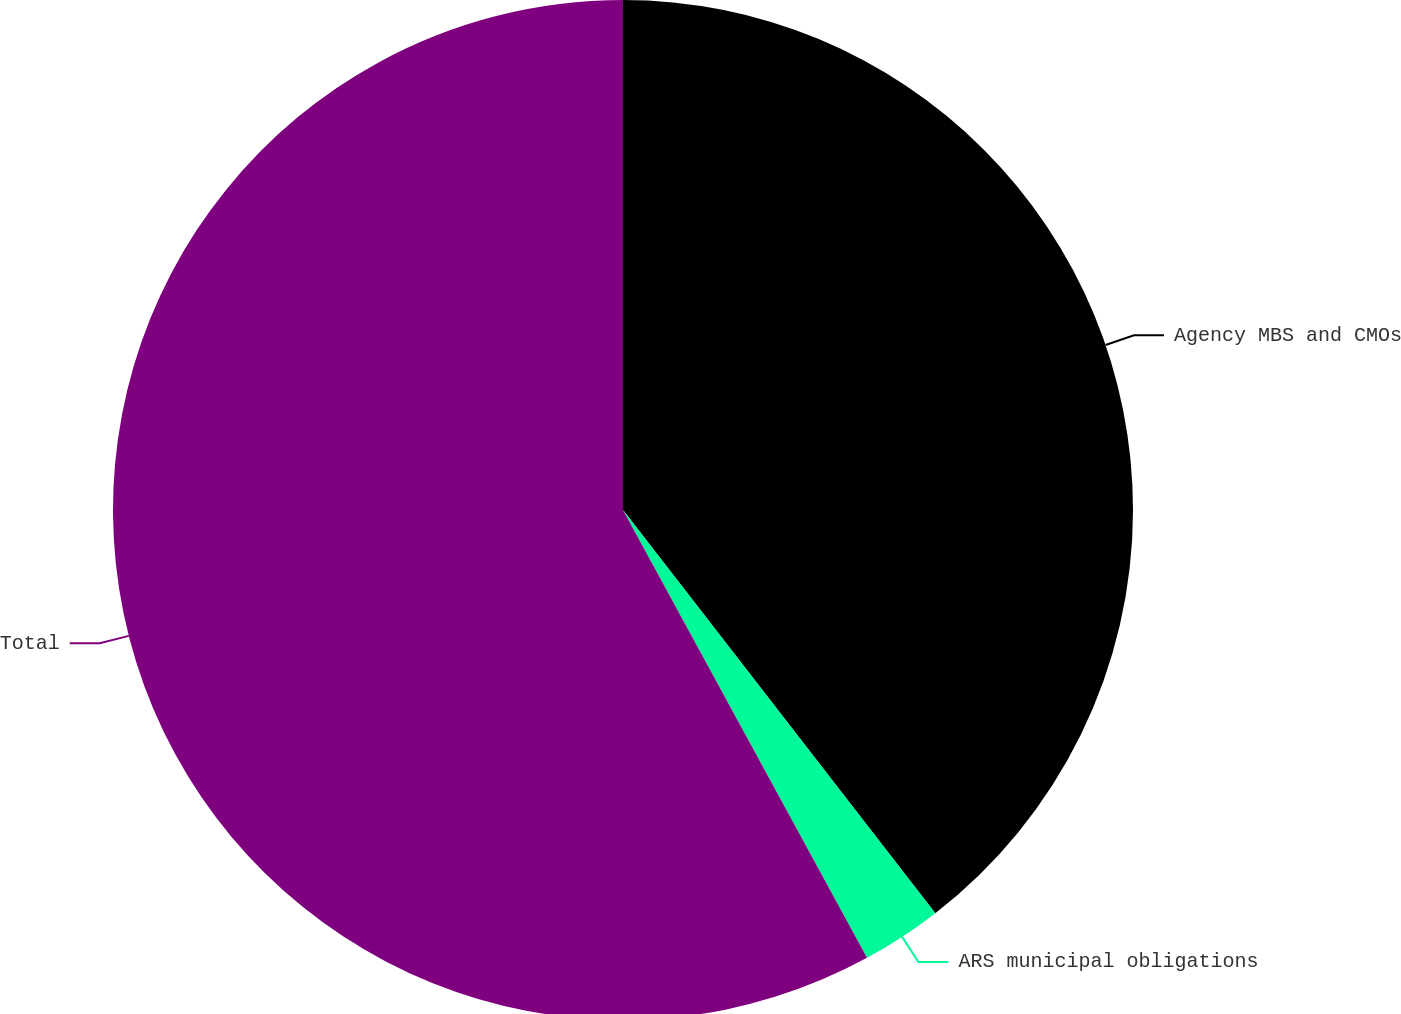Convert chart to OTSL. <chart><loc_0><loc_0><loc_500><loc_500><pie_chart><fcel>Agency MBS and CMOs<fcel>ARS municipal obligations<fcel>Total<nl><fcel>39.51%<fcel>2.55%<fcel>57.94%<nl></chart> 